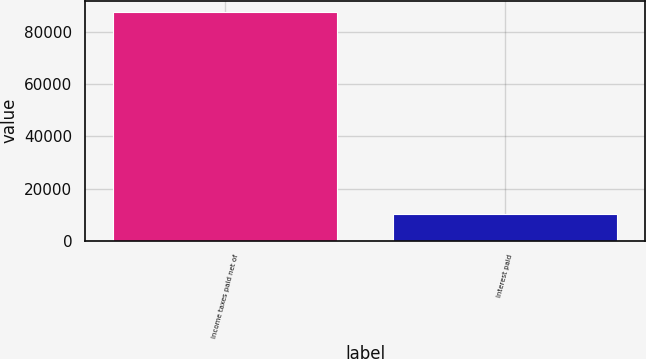Convert chart. <chart><loc_0><loc_0><loc_500><loc_500><bar_chart><fcel>Income taxes paid net of<fcel>Interest paid<nl><fcel>87591<fcel>10425<nl></chart> 